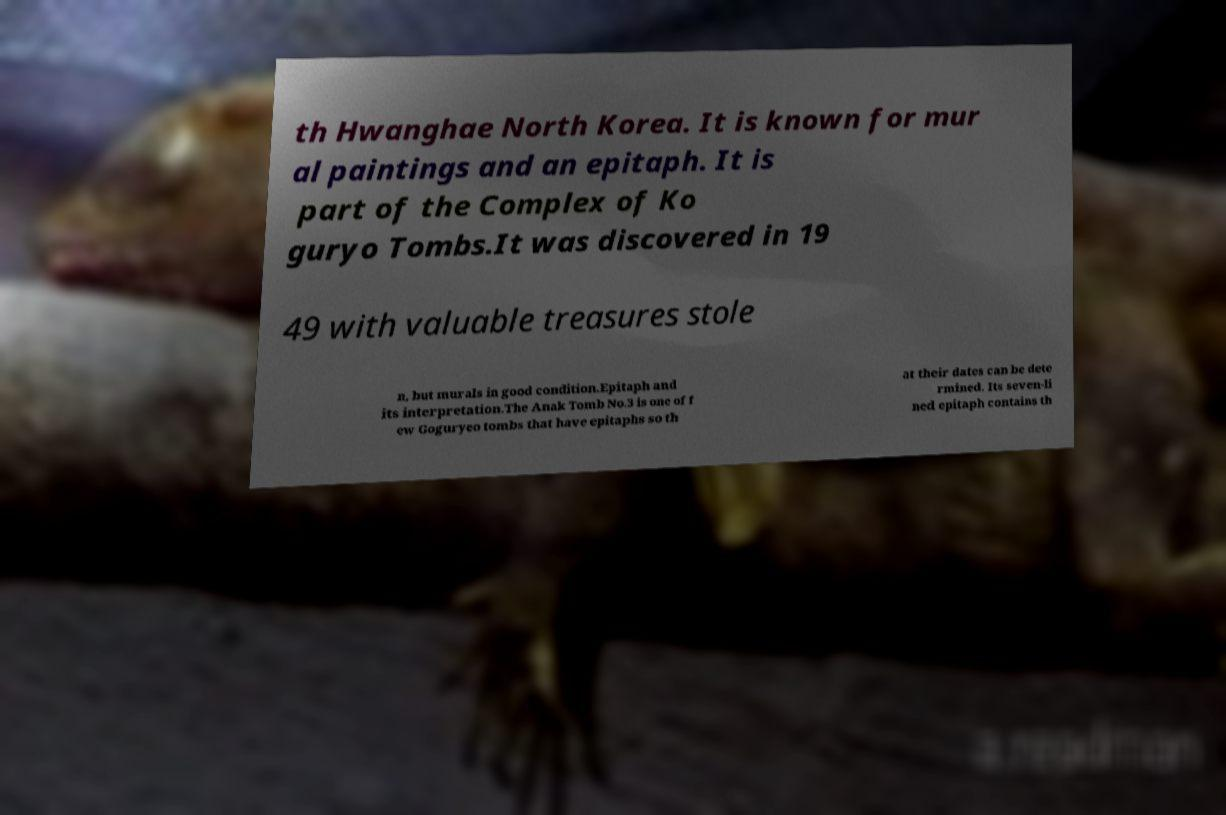Please read and relay the text visible in this image. What does it say? th Hwanghae North Korea. It is known for mur al paintings and an epitaph. It is part of the Complex of Ko guryo Tombs.It was discovered in 19 49 with valuable treasures stole n, but murals in good condition.Epitaph and its interpretation.The Anak Tomb No.3 is one of f ew Goguryeo tombs that have epitaphs so th at their dates can be dete rmined. Its seven-li ned epitaph contains th 